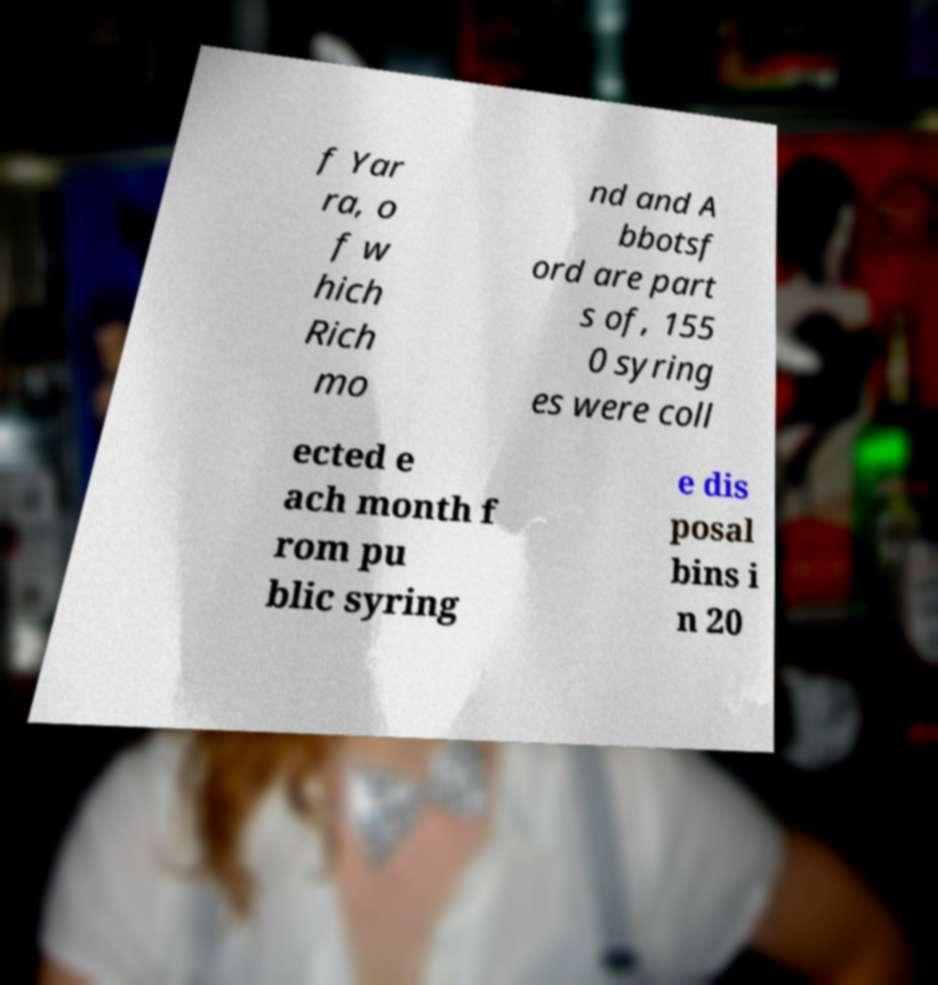There's text embedded in this image that I need extracted. Can you transcribe it verbatim? f Yar ra, o f w hich Rich mo nd and A bbotsf ord are part s of, 155 0 syring es were coll ected e ach month f rom pu blic syring e dis posal bins i n 20 